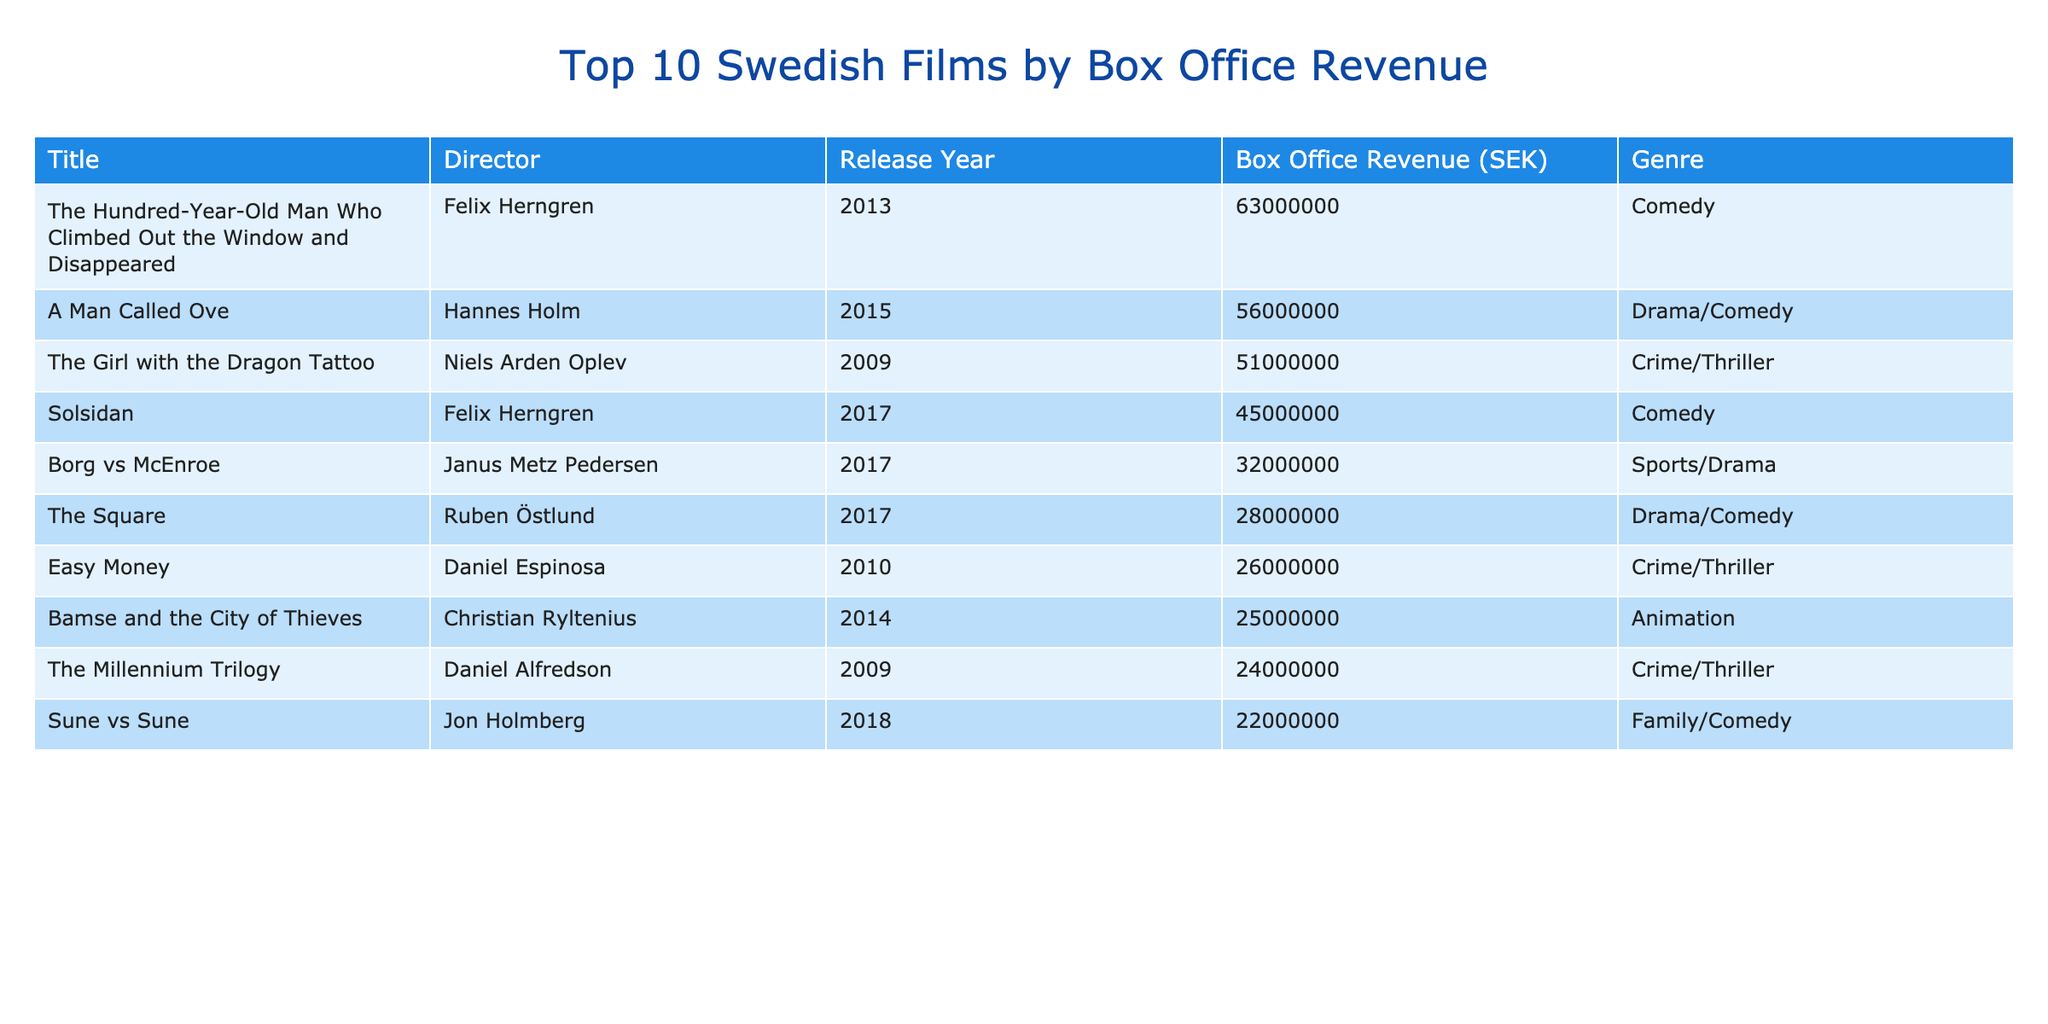What is the title of the film with the highest box office revenue? The highest box office revenue in the table is 63,000,000 SEK. Looking at the Titles in the table, "The Hundred-Year-Old Man Who Climbed Out the Window and Disappeared" corresponds to this revenue.
Answer: The Hundred-Year-Old Man Who Climbed Out the Window and Disappeared Which film was directed by Hannes Holm? The director Hannes Holm is associated with the film "A Man Called Ove," which is listed in the table.
Answer: A Man Called Ove What is the box office revenue of "Solsidan"? According to the table, "Solsidan" had a box office revenue of 45,000,000 SEK.
Answer: 45,000,000 SEK How many films in the table fall under the genre Comedy? The table lists "The Hundred-Year-Old Man Who Climbed Out the Window and Disappeared," "Solsidan," and "Sune vs Sune" as Comedy films, totaling three films.
Answer: 3 What is the average box office revenue of the films in the table? To find the average, sum all box office revenues: 63,000,000 + 56,000,000 + 51,000,000 + 45,000,000 + 32,000,000 + 28,000,000 + 26,000,000 + 25,000,000 + 24,000,000 + 22,000,000 =  353,000,000, then divide by 10, giving an average of 35,300,000 SEK.
Answer: 35,300,000 SEK Is "The Girl with the Dragon Tattoo" among the top 10 films based on box office revenue? Yes, the film "The Girl with the Dragon Tattoo" is included in the table with a revenue of 51,000,000 SEK.
Answer: Yes What is the box office revenue difference between "A Man Called Ove" and "Borg vs McEnroe"? The box office revenue for "A Man Called Ove" is 56,000,000 SEK, and for "Borg vs McEnroe," it is 32,000,000 SEK. The difference is 56,000,000 - 32,000,000 = 24,000,000 SEK.
Answer: 24,000,000 SEK Which film has the lowest box office revenue? "Sune vs Sune" has the lowest box office revenue according to the table, at 22,000,000 SEK.
Answer: Sune vs Sune What is the total box office revenue of all the films directed by Felix Herngren? Felix Herngren directed "The Hundred-Year-Old Man Who Climbed Out the Window and Disappeared" and "Solsidan." Their revenues are 63,000,000 and 45,000,000 SEK, respectively, totaling 63,000,000 + 45,000,000 = 108,000,000 SEK.
Answer: 108,000,000 SEK How many films in the table were released in 2017? There are three films released in 2017, which are "Solsidan," "Borg vs McEnroe," and "The Square."
Answer: 3 Did any film in the table have a box office revenue over 60 million SEK? Yes, "The Hundred-Year-Old Man Who Climbed Out the Window and Disappeared" is the only film that achieved over 60 million SEK.
Answer: Yes 